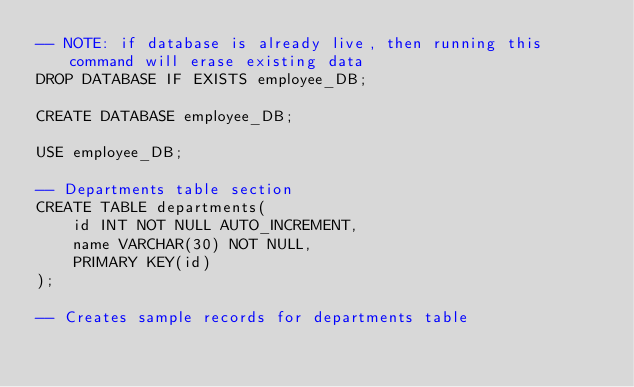<code> <loc_0><loc_0><loc_500><loc_500><_SQL_>-- NOTE: if database is already live, then running this command will erase existing data
DROP DATABASE IF EXISTS employee_DB;

CREATE DATABASE employee_DB;

USE employee_DB;

-- Departments table section
CREATE TABLE departments(
    id INT NOT NULL AUTO_INCREMENT,
    name VARCHAR(30) NOT NULL,
    PRIMARY KEY(id)
);

-- Creates sample records for departments table</code> 